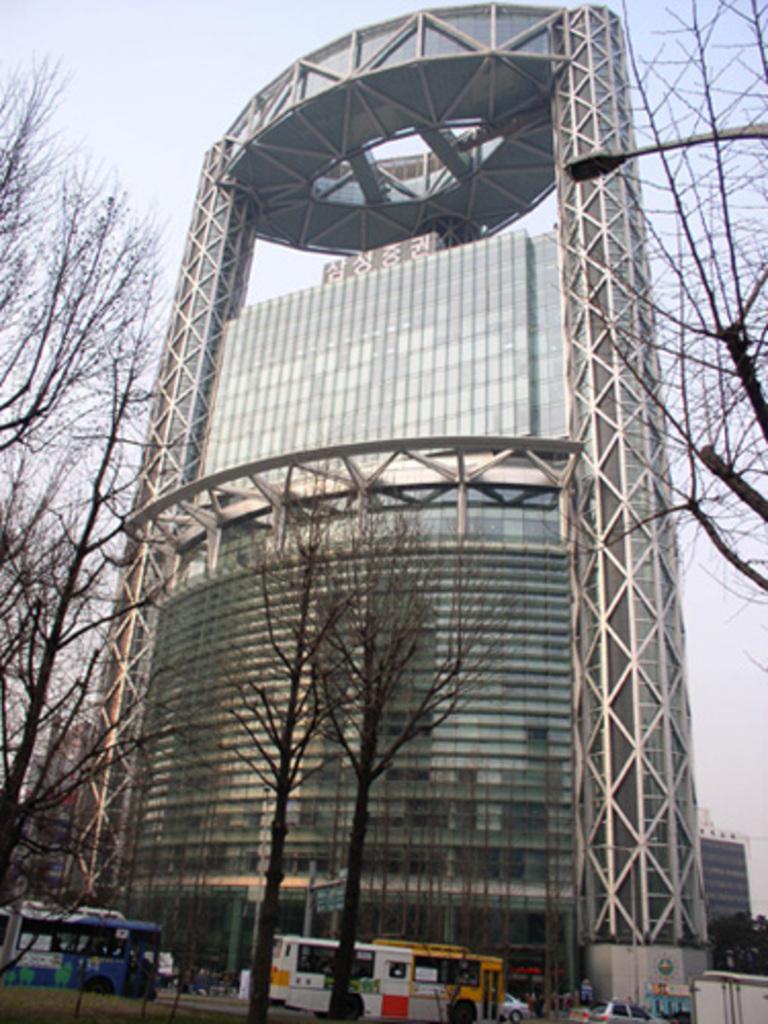Could you give a brief overview of what you see in this image? In this image I can see few trees, two buses on the road, few other vehicles on the road, a street light and few buildings. In the background I can see the sky. 